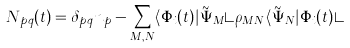Convert formula to latex. <formula><loc_0><loc_0><loc_500><loc_500>N _ { p q } ( t ) = \delta _ { p q } n _ { p } - \sum _ { M , N } \langle \Phi _ { i } ( t ) | \tilde { \Psi } _ { M } \rangle \rho _ { M N } \langle \tilde { \Psi } _ { N } | \Phi _ { i } ( t ) \rangle</formula> 